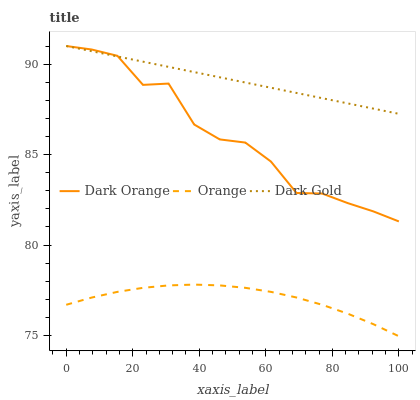Does Orange have the minimum area under the curve?
Answer yes or no. Yes. Does Dark Gold have the maximum area under the curve?
Answer yes or no. Yes. Does Dark Orange have the minimum area under the curve?
Answer yes or no. No. Does Dark Orange have the maximum area under the curve?
Answer yes or no. No. Is Dark Gold the smoothest?
Answer yes or no. Yes. Is Dark Orange the roughest?
Answer yes or no. Yes. Is Dark Orange the smoothest?
Answer yes or no. No. Is Dark Gold the roughest?
Answer yes or no. No. Does Orange have the lowest value?
Answer yes or no. Yes. Does Dark Orange have the lowest value?
Answer yes or no. No. Does Dark Gold have the highest value?
Answer yes or no. Yes. Does Dark Orange have the highest value?
Answer yes or no. No. Is Orange less than Dark Orange?
Answer yes or no. Yes. Is Dark Orange greater than Orange?
Answer yes or no. Yes. Does Dark Orange intersect Dark Gold?
Answer yes or no. Yes. Is Dark Orange less than Dark Gold?
Answer yes or no. No. Is Dark Orange greater than Dark Gold?
Answer yes or no. No. Does Orange intersect Dark Orange?
Answer yes or no. No. 